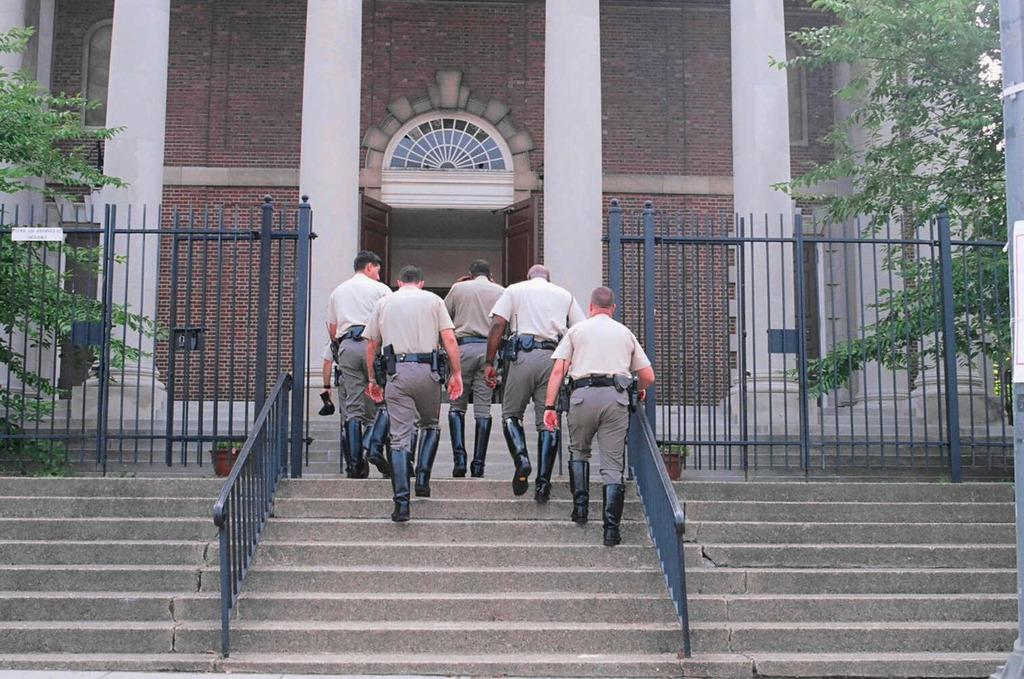What are the people in the image doing? The people in the image are walking on the stairs. Where are the people going? The people are entering a building. What can be seen on either side of the stairs? There are trees on either side of the stairs. What type of butter is being used to write on the trees in the image? There is no butter or writing on the trees in the image; it only shows people walking on the stairs and trees on either side. 